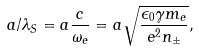<formula> <loc_0><loc_0><loc_500><loc_500>a / \lambda _ { S } = a \frac { c } { \omega _ { e } } = a \sqrt { \frac { \epsilon _ { 0 } \gamma m _ { e } } { e ^ { 2 } n _ { \pm } } } ,</formula> 